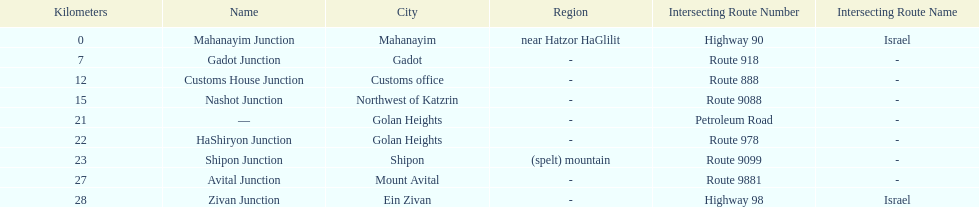What junction is the furthest from mahanayim junction? Zivan Junction. 